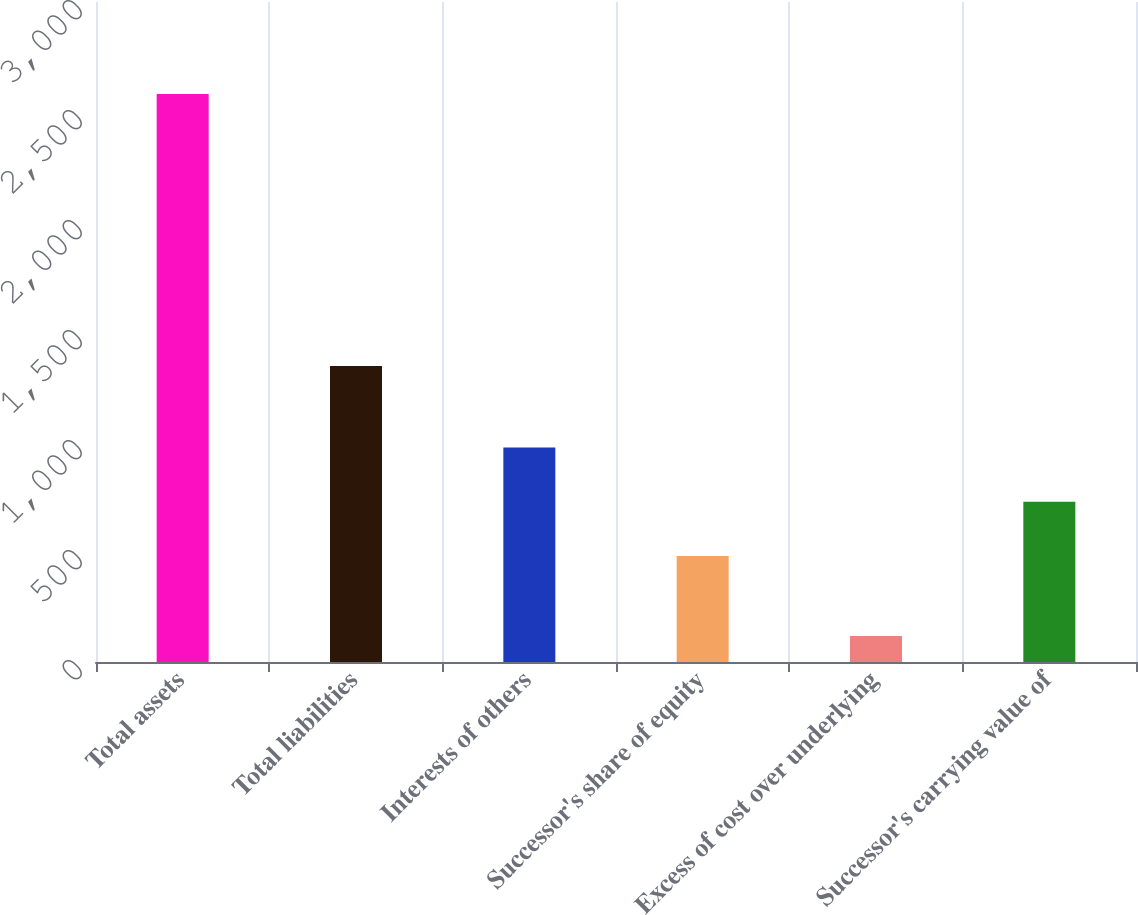Convert chart. <chart><loc_0><loc_0><loc_500><loc_500><bar_chart><fcel>Total assets<fcel>Total liabilities<fcel>Interests of others<fcel>Successor's share of equity<fcel>Excess of cost over underlying<fcel>Successor's carrying value of<nl><fcel>2582<fcel>1346<fcel>974.8<fcel>482<fcel>118<fcel>728.4<nl></chart> 